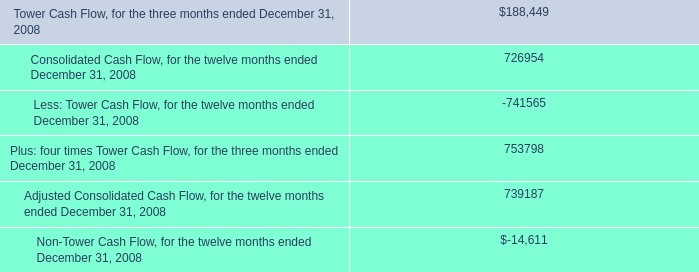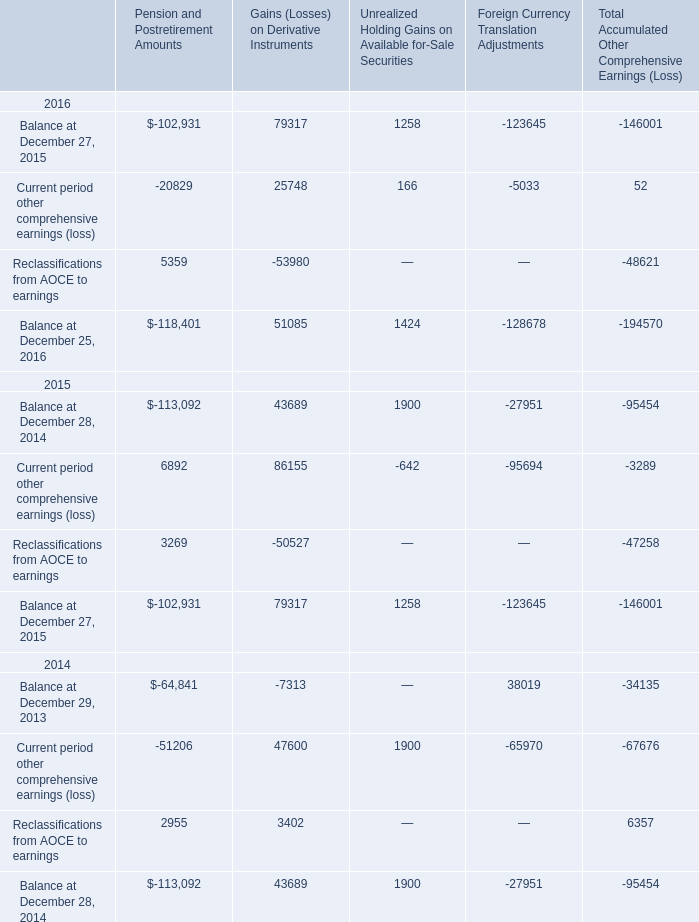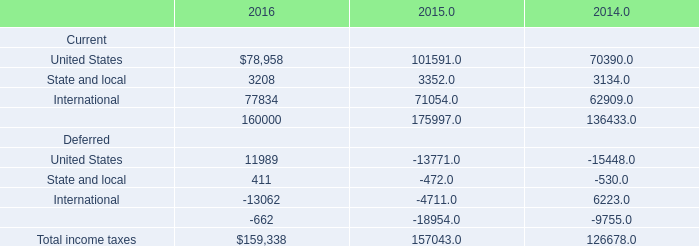What's the sum of Balance at December 27, 2015 of Foreign Currency Translation Adjustments, and United States of 2016 ? 
Computations: (123645.0 + 78958.0)
Answer: 202603.0. 